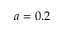<formula> <loc_0><loc_0><loc_500><loc_500>a = 0 . 2</formula> 